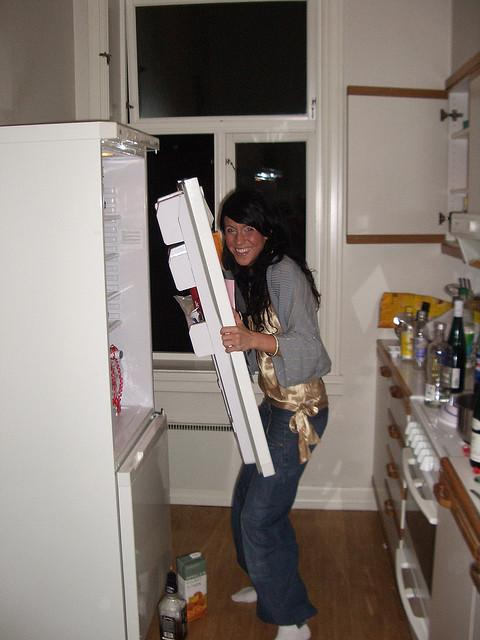What will happen to the refrigerator next?

Choices:
A) nothing
B) chilling
C) freezing
D) warm up warm up 